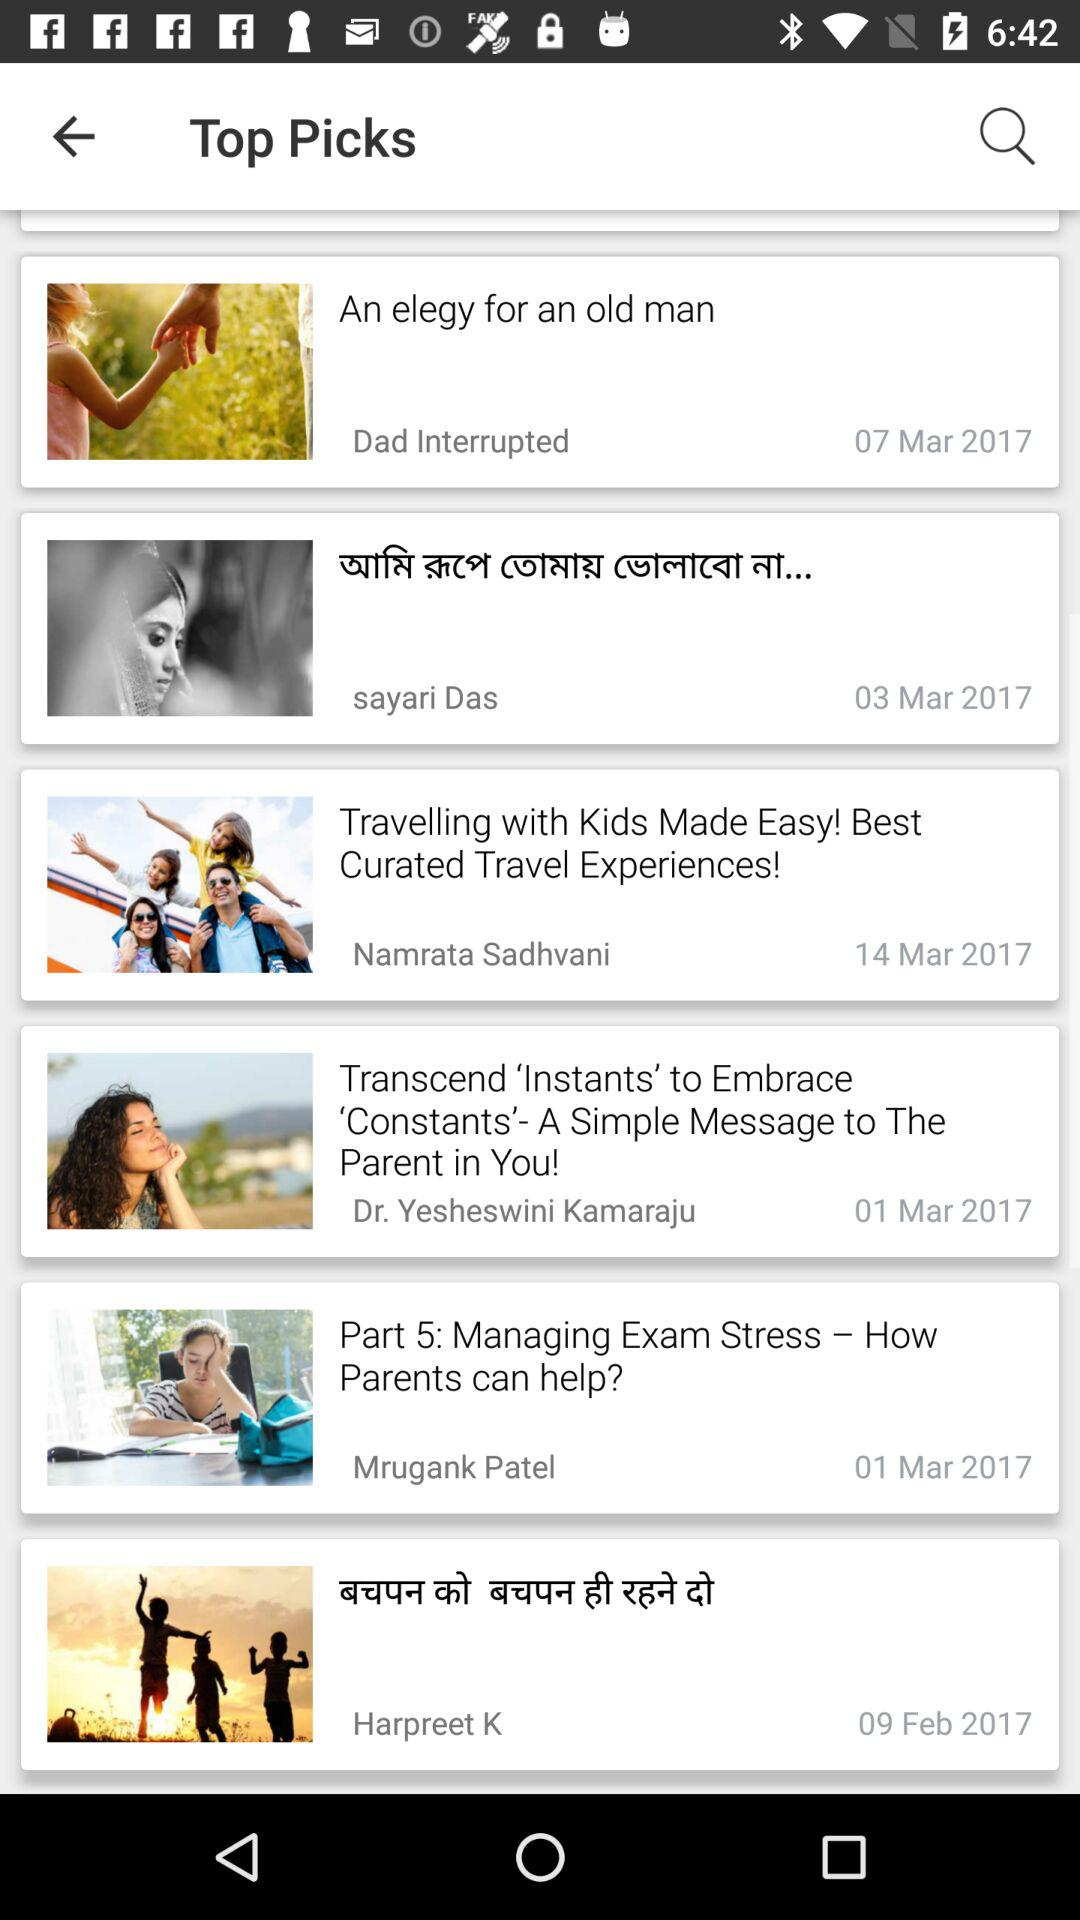Who is the author of "Part 5: Managing Exam Stress"? The author is Mrugank Patel. 